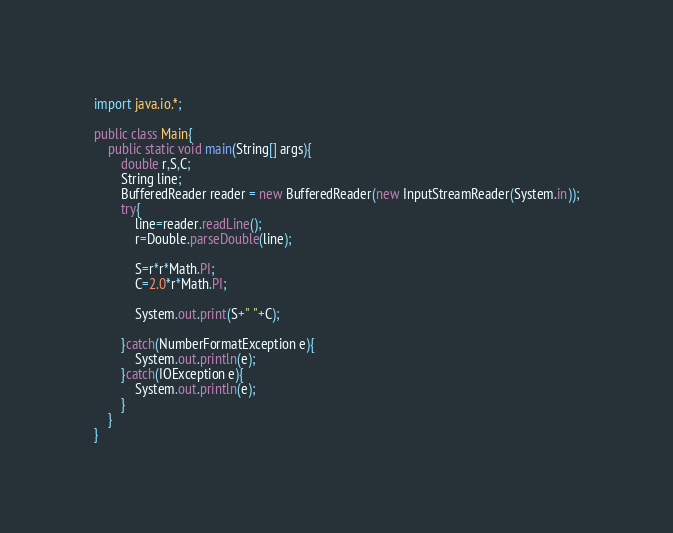<code> <loc_0><loc_0><loc_500><loc_500><_Java_>import java.io.*;

public class Main{
    public static void main(String[] args){
        double r,S,C;
        String line;
        BufferedReader reader = new BufferedReader(new InputStreamReader(System.in));
        try{
            line=reader.readLine();
            r=Double.parseDouble(line);

            S=r*r*Math.PI;
            C=2.0*r*Math.PI;
            
            System.out.print(S+" "+C);

        }catch(NumberFormatException e){
            System.out.println(e);
        }catch(IOException e){
            System.out.println(e);
        }
    }
}
</code> 